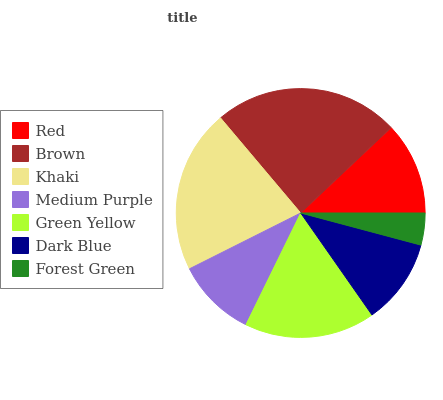Is Forest Green the minimum?
Answer yes or no. Yes. Is Brown the maximum?
Answer yes or no. Yes. Is Khaki the minimum?
Answer yes or no. No. Is Khaki the maximum?
Answer yes or no. No. Is Brown greater than Khaki?
Answer yes or no. Yes. Is Khaki less than Brown?
Answer yes or no. Yes. Is Khaki greater than Brown?
Answer yes or no. No. Is Brown less than Khaki?
Answer yes or no. No. Is Red the high median?
Answer yes or no. Yes. Is Red the low median?
Answer yes or no. Yes. Is Medium Purple the high median?
Answer yes or no. No. Is Brown the low median?
Answer yes or no. No. 